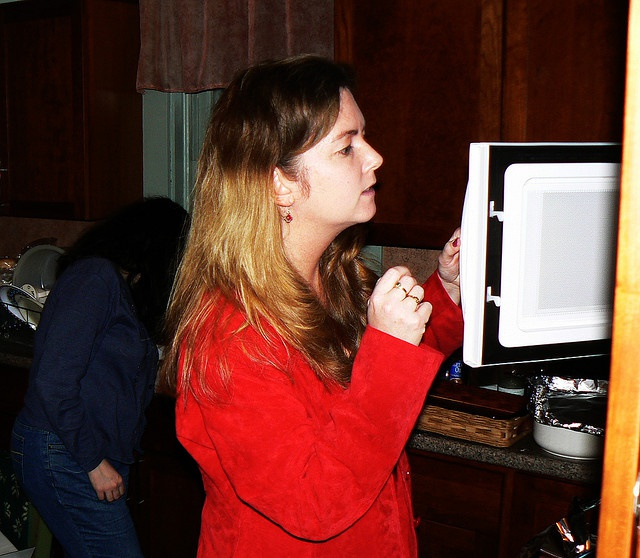Describe the objects in this image and their specific colors. I can see people in gray, red, black, brown, and maroon tones, people in gray, black, brown, and maroon tones, microwave in gray, white, black, and darkgray tones, bowl in gray, darkgray, black, and lightgray tones, and bowl in gray and black tones in this image. 